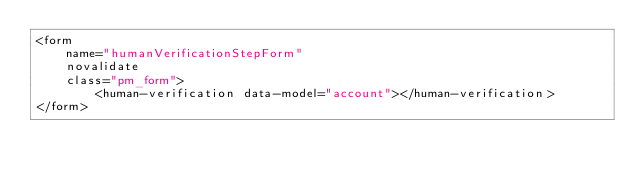Convert code to text. <code><loc_0><loc_0><loc_500><loc_500><_HTML_><form
    name="humanVerificationStepForm"
    novalidate
    class="pm_form">
        <human-verification data-model="account"></human-verification>
</form>
</code> 